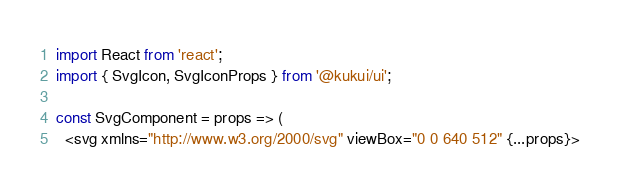Convert code to text. <code><loc_0><loc_0><loc_500><loc_500><_TypeScript_>import React from 'react';
import { SvgIcon, SvgIconProps } from '@kukui/ui';

const SvgComponent = props => (
  <svg xmlns="http://www.w3.org/2000/svg" viewBox="0 0 640 512" {...props}></code> 